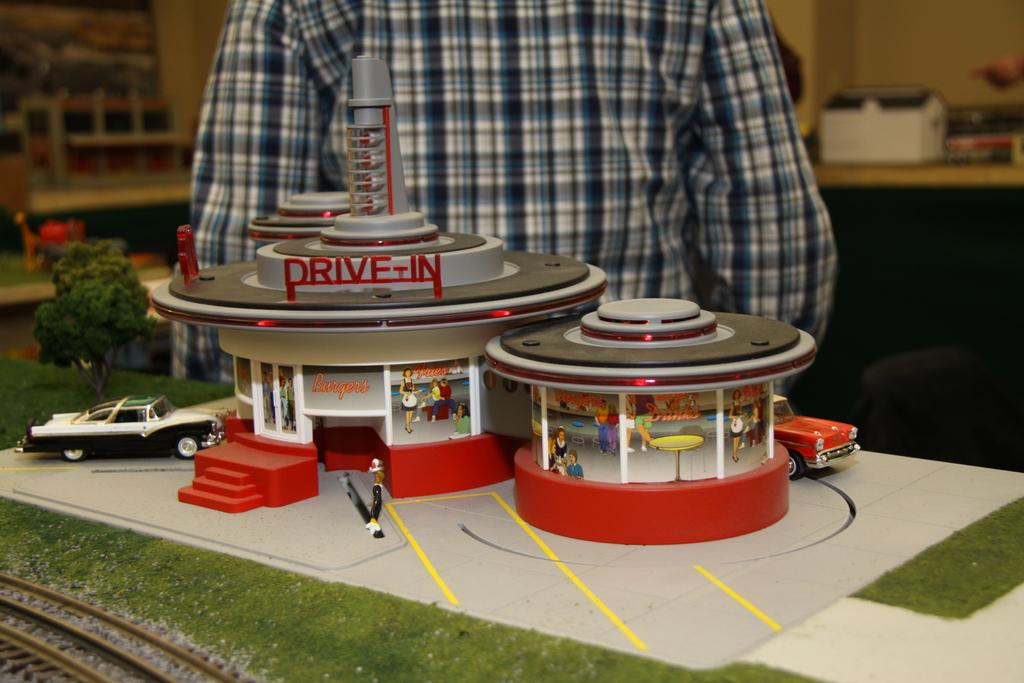<image>
Offer a succinct explanation of the picture presented. A children's toy that is part of a railroad set that has a drive-in. 